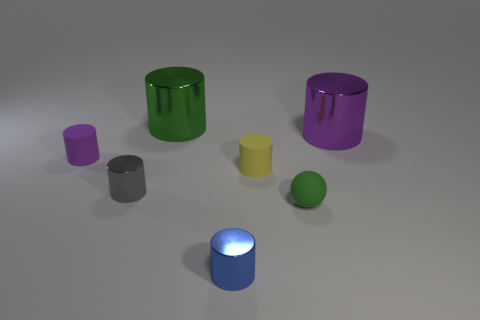What might the different materials and colors represent in this setup? The various materials and colors in this image could signify a number of concepts. The reflective surfaces of the green and purple cylinders, as well as the green sphere, might indicate materials like polished metal or plastic, which are often used in visualizations to demonstrate properties such as glossiness and reflectivity. The matte yellow cylinder could represent a more diffuse surface, similar to painted metal or ceramic, which absorbs light rather than reflecting it. The blue glowing cylinder could symbolize a light-emitting object, possibly LED or another artificial light source, and it stands out due to its distinct luminance compared to the other objects. 